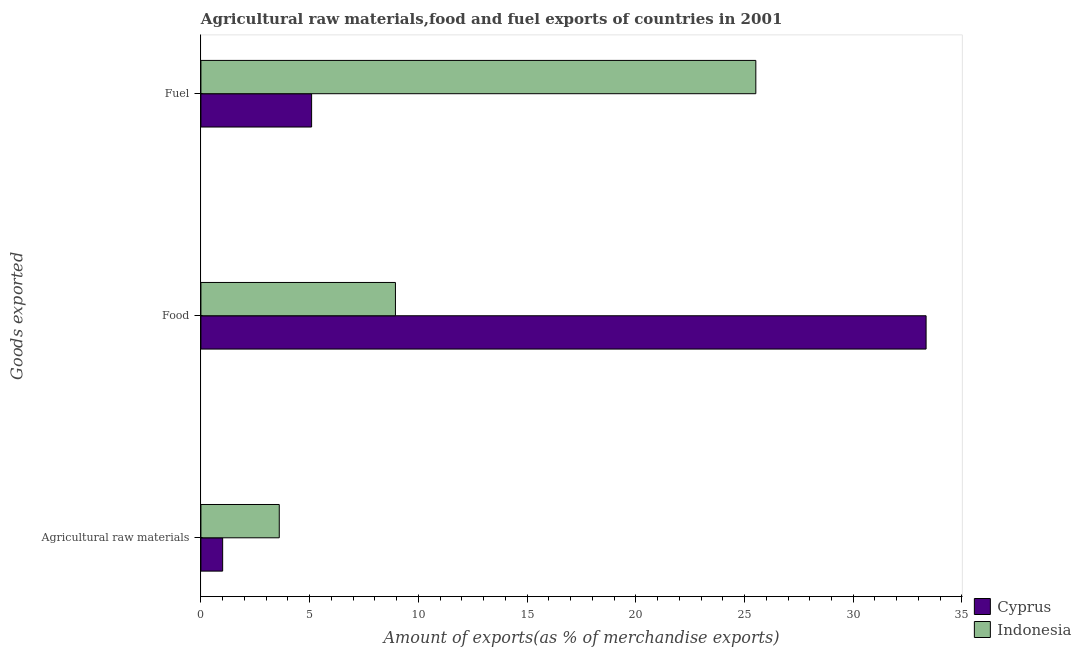How many bars are there on the 3rd tick from the bottom?
Offer a terse response. 2. What is the label of the 3rd group of bars from the top?
Keep it short and to the point. Agricultural raw materials. What is the percentage of fuel exports in Indonesia?
Provide a succinct answer. 25.52. Across all countries, what is the maximum percentage of fuel exports?
Ensure brevity in your answer.  25.52. Across all countries, what is the minimum percentage of fuel exports?
Keep it short and to the point. 5.09. In which country was the percentage of raw materials exports minimum?
Your answer should be compact. Cyprus. What is the total percentage of food exports in the graph?
Provide a short and direct response. 42.3. What is the difference between the percentage of raw materials exports in Indonesia and that in Cyprus?
Provide a succinct answer. 2.6. What is the difference between the percentage of food exports in Indonesia and the percentage of fuel exports in Cyprus?
Make the answer very short. 3.86. What is the average percentage of food exports per country?
Provide a short and direct response. 21.15. What is the difference between the percentage of raw materials exports and percentage of food exports in Indonesia?
Your answer should be very brief. -5.34. In how many countries, is the percentage of raw materials exports greater than 13 %?
Your response must be concise. 0. What is the ratio of the percentage of food exports in Indonesia to that in Cyprus?
Make the answer very short. 0.27. Is the percentage of raw materials exports in Cyprus less than that in Indonesia?
Your answer should be compact. Yes. What is the difference between the highest and the second highest percentage of food exports?
Your answer should be very brief. 24.4. What is the difference between the highest and the lowest percentage of food exports?
Make the answer very short. 24.4. Is the sum of the percentage of food exports in Indonesia and Cyprus greater than the maximum percentage of raw materials exports across all countries?
Offer a terse response. Yes. What does the 2nd bar from the top in Food represents?
Ensure brevity in your answer.  Cyprus. What does the 1st bar from the bottom in Fuel represents?
Your answer should be compact. Cyprus. Is it the case that in every country, the sum of the percentage of raw materials exports and percentage of food exports is greater than the percentage of fuel exports?
Keep it short and to the point. No. How many bars are there?
Offer a very short reply. 6. How many countries are there in the graph?
Keep it short and to the point. 2. What is the difference between two consecutive major ticks on the X-axis?
Provide a short and direct response. 5. Does the graph contain grids?
Your response must be concise. No. Where does the legend appear in the graph?
Make the answer very short. Bottom right. How many legend labels are there?
Your response must be concise. 2. What is the title of the graph?
Offer a very short reply. Agricultural raw materials,food and fuel exports of countries in 2001. What is the label or title of the X-axis?
Make the answer very short. Amount of exports(as % of merchandise exports). What is the label or title of the Y-axis?
Ensure brevity in your answer.  Goods exported. What is the Amount of exports(as % of merchandise exports) in Cyprus in Agricultural raw materials?
Ensure brevity in your answer.  1. What is the Amount of exports(as % of merchandise exports) of Indonesia in Agricultural raw materials?
Offer a terse response. 3.6. What is the Amount of exports(as % of merchandise exports) in Cyprus in Food?
Make the answer very short. 33.35. What is the Amount of exports(as % of merchandise exports) in Indonesia in Food?
Make the answer very short. 8.95. What is the Amount of exports(as % of merchandise exports) in Cyprus in Fuel?
Make the answer very short. 5.09. What is the Amount of exports(as % of merchandise exports) of Indonesia in Fuel?
Provide a short and direct response. 25.52. Across all Goods exported, what is the maximum Amount of exports(as % of merchandise exports) in Cyprus?
Offer a very short reply. 33.35. Across all Goods exported, what is the maximum Amount of exports(as % of merchandise exports) of Indonesia?
Make the answer very short. 25.52. Across all Goods exported, what is the minimum Amount of exports(as % of merchandise exports) in Cyprus?
Make the answer very short. 1. Across all Goods exported, what is the minimum Amount of exports(as % of merchandise exports) in Indonesia?
Keep it short and to the point. 3.6. What is the total Amount of exports(as % of merchandise exports) in Cyprus in the graph?
Provide a succinct answer. 39.44. What is the total Amount of exports(as % of merchandise exports) of Indonesia in the graph?
Offer a very short reply. 38.07. What is the difference between the Amount of exports(as % of merchandise exports) of Cyprus in Agricultural raw materials and that in Food?
Your answer should be compact. -32.35. What is the difference between the Amount of exports(as % of merchandise exports) in Indonesia in Agricultural raw materials and that in Food?
Give a very brief answer. -5.34. What is the difference between the Amount of exports(as % of merchandise exports) in Cyprus in Agricultural raw materials and that in Fuel?
Keep it short and to the point. -4.09. What is the difference between the Amount of exports(as % of merchandise exports) in Indonesia in Agricultural raw materials and that in Fuel?
Keep it short and to the point. -21.92. What is the difference between the Amount of exports(as % of merchandise exports) in Cyprus in Food and that in Fuel?
Give a very brief answer. 28.26. What is the difference between the Amount of exports(as % of merchandise exports) in Indonesia in Food and that in Fuel?
Provide a short and direct response. -16.57. What is the difference between the Amount of exports(as % of merchandise exports) of Cyprus in Agricultural raw materials and the Amount of exports(as % of merchandise exports) of Indonesia in Food?
Your response must be concise. -7.95. What is the difference between the Amount of exports(as % of merchandise exports) in Cyprus in Agricultural raw materials and the Amount of exports(as % of merchandise exports) in Indonesia in Fuel?
Your answer should be very brief. -24.52. What is the difference between the Amount of exports(as % of merchandise exports) of Cyprus in Food and the Amount of exports(as % of merchandise exports) of Indonesia in Fuel?
Your response must be concise. 7.83. What is the average Amount of exports(as % of merchandise exports) of Cyprus per Goods exported?
Keep it short and to the point. 13.15. What is the average Amount of exports(as % of merchandise exports) of Indonesia per Goods exported?
Make the answer very short. 12.69. What is the difference between the Amount of exports(as % of merchandise exports) in Cyprus and Amount of exports(as % of merchandise exports) in Indonesia in Agricultural raw materials?
Provide a succinct answer. -2.6. What is the difference between the Amount of exports(as % of merchandise exports) of Cyprus and Amount of exports(as % of merchandise exports) of Indonesia in Food?
Provide a short and direct response. 24.4. What is the difference between the Amount of exports(as % of merchandise exports) in Cyprus and Amount of exports(as % of merchandise exports) in Indonesia in Fuel?
Your response must be concise. -20.43. What is the ratio of the Amount of exports(as % of merchandise exports) in Cyprus in Agricultural raw materials to that in Food?
Keep it short and to the point. 0.03. What is the ratio of the Amount of exports(as % of merchandise exports) in Indonesia in Agricultural raw materials to that in Food?
Offer a very short reply. 0.4. What is the ratio of the Amount of exports(as % of merchandise exports) in Cyprus in Agricultural raw materials to that in Fuel?
Your response must be concise. 0.2. What is the ratio of the Amount of exports(as % of merchandise exports) of Indonesia in Agricultural raw materials to that in Fuel?
Ensure brevity in your answer.  0.14. What is the ratio of the Amount of exports(as % of merchandise exports) of Cyprus in Food to that in Fuel?
Keep it short and to the point. 6.55. What is the ratio of the Amount of exports(as % of merchandise exports) in Indonesia in Food to that in Fuel?
Offer a terse response. 0.35. What is the difference between the highest and the second highest Amount of exports(as % of merchandise exports) in Cyprus?
Your answer should be very brief. 28.26. What is the difference between the highest and the second highest Amount of exports(as % of merchandise exports) in Indonesia?
Your answer should be compact. 16.57. What is the difference between the highest and the lowest Amount of exports(as % of merchandise exports) of Cyprus?
Make the answer very short. 32.35. What is the difference between the highest and the lowest Amount of exports(as % of merchandise exports) of Indonesia?
Your answer should be very brief. 21.92. 